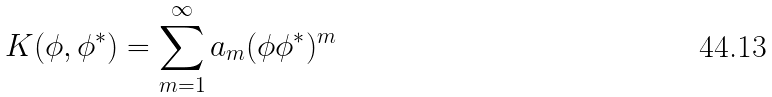Convert formula to latex. <formula><loc_0><loc_0><loc_500><loc_500>K ( \phi , \phi ^ { * } ) = \sum _ { m = 1 } ^ { \infty } a _ { m } ( \phi \phi ^ { * } ) ^ { m }</formula> 